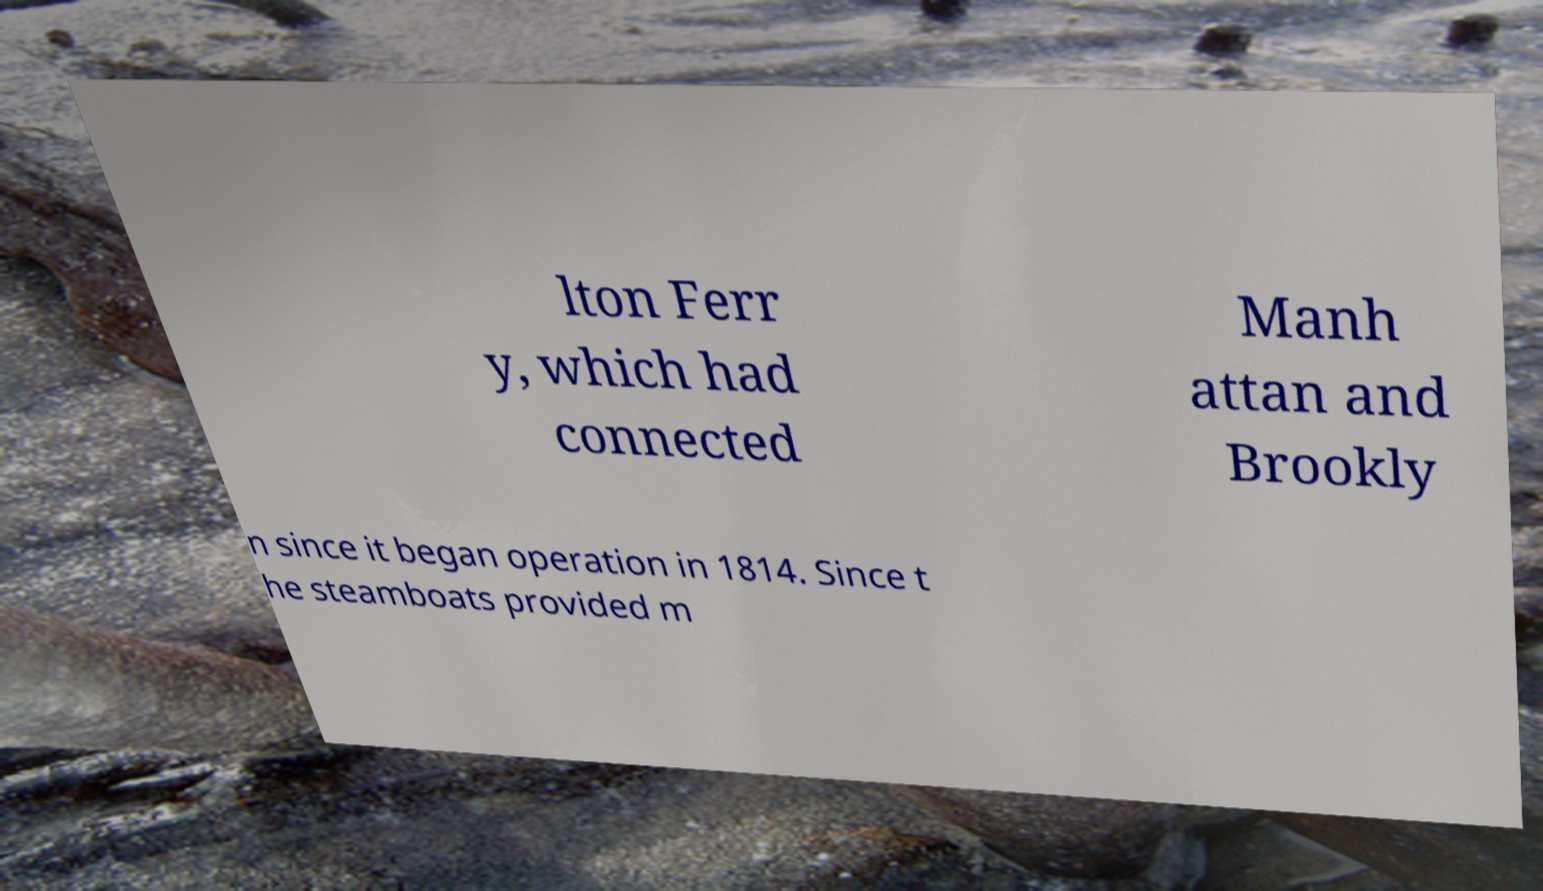Please identify and transcribe the text found in this image. lton Ferr y, which had connected Manh attan and Brookly n since it began operation in 1814. Since t he steamboats provided m 